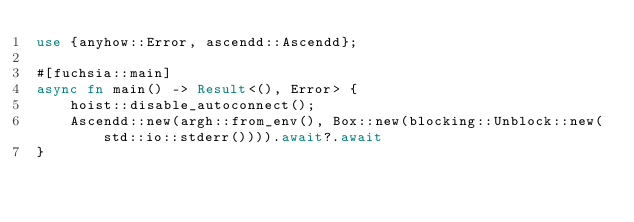Convert code to text. <code><loc_0><loc_0><loc_500><loc_500><_Rust_>use {anyhow::Error, ascendd::Ascendd};

#[fuchsia::main]
async fn main() -> Result<(), Error> {
    hoist::disable_autoconnect();
    Ascendd::new(argh::from_env(), Box::new(blocking::Unblock::new(std::io::stderr()))).await?.await
}
</code> 